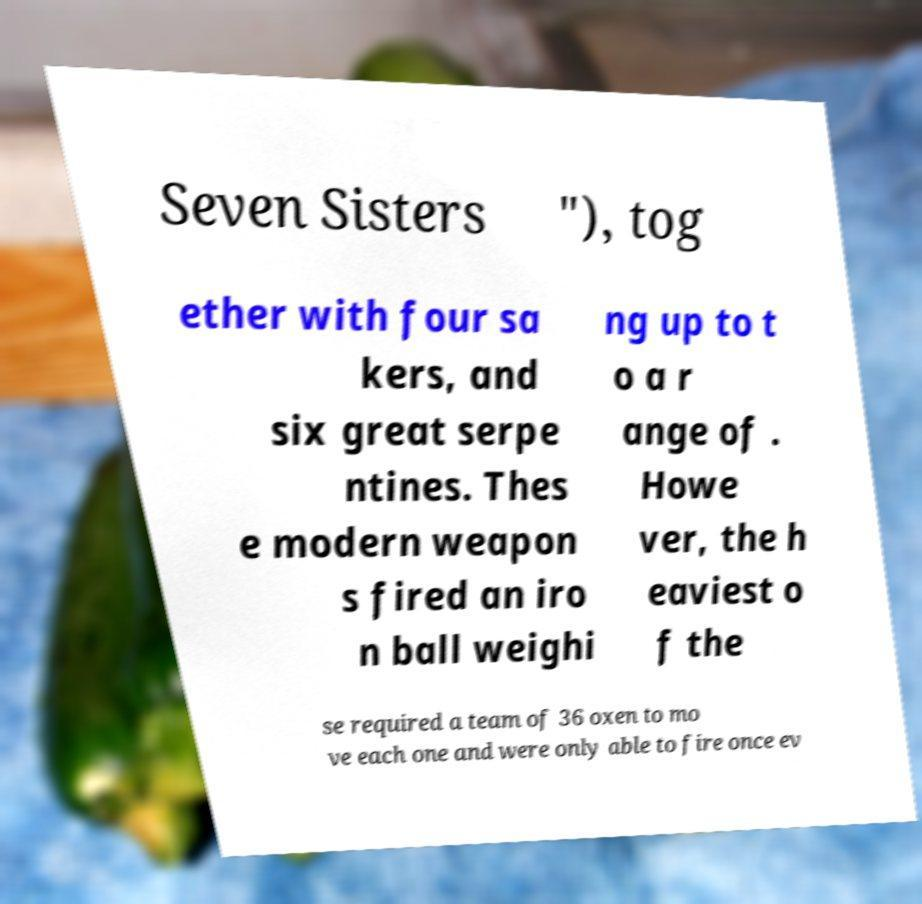What messages or text are displayed in this image? I need them in a readable, typed format. Seven Sisters "), tog ether with four sa kers, and six great serpe ntines. Thes e modern weapon s fired an iro n ball weighi ng up to t o a r ange of . Howe ver, the h eaviest o f the se required a team of 36 oxen to mo ve each one and were only able to fire once ev 